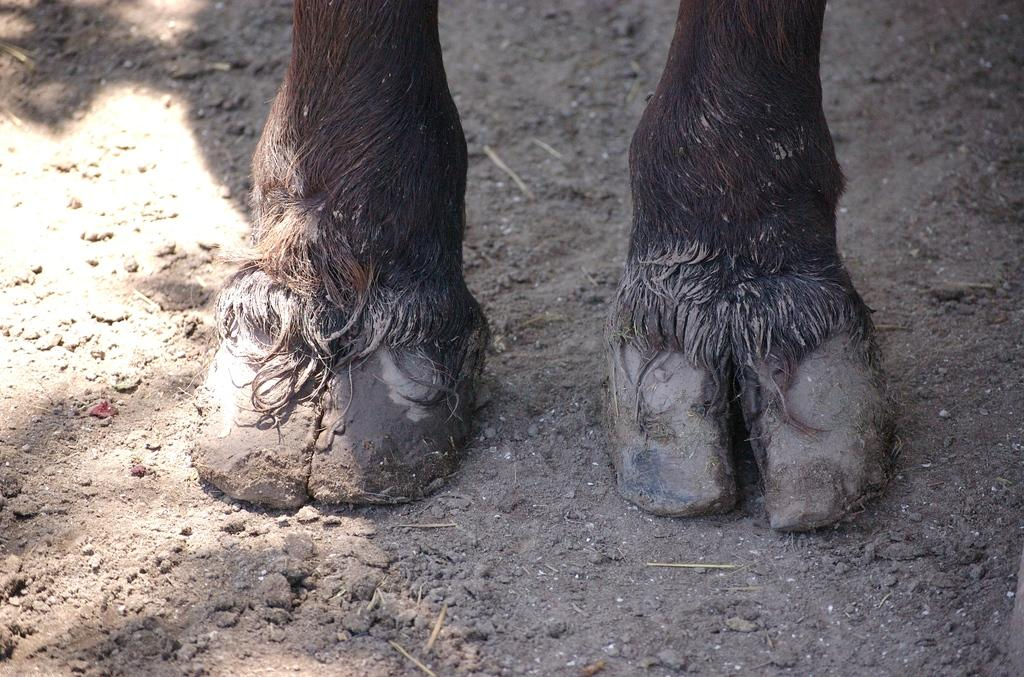What type of animal is present in the image? The image shows the legs of an animal, but it does not specify the type of animal. What is the surface under the animal's legs? The ground in the image is sand. How many pieces of popcorn are scattered on the sand in the image? There is no popcorn present in the image; it only shows the legs of an animal and sandy ground. What type of bird is sitting in the middle of the image? There is no bird, specifically a wren, present in the image; it only shows the legs of an animal and sandy ground. 